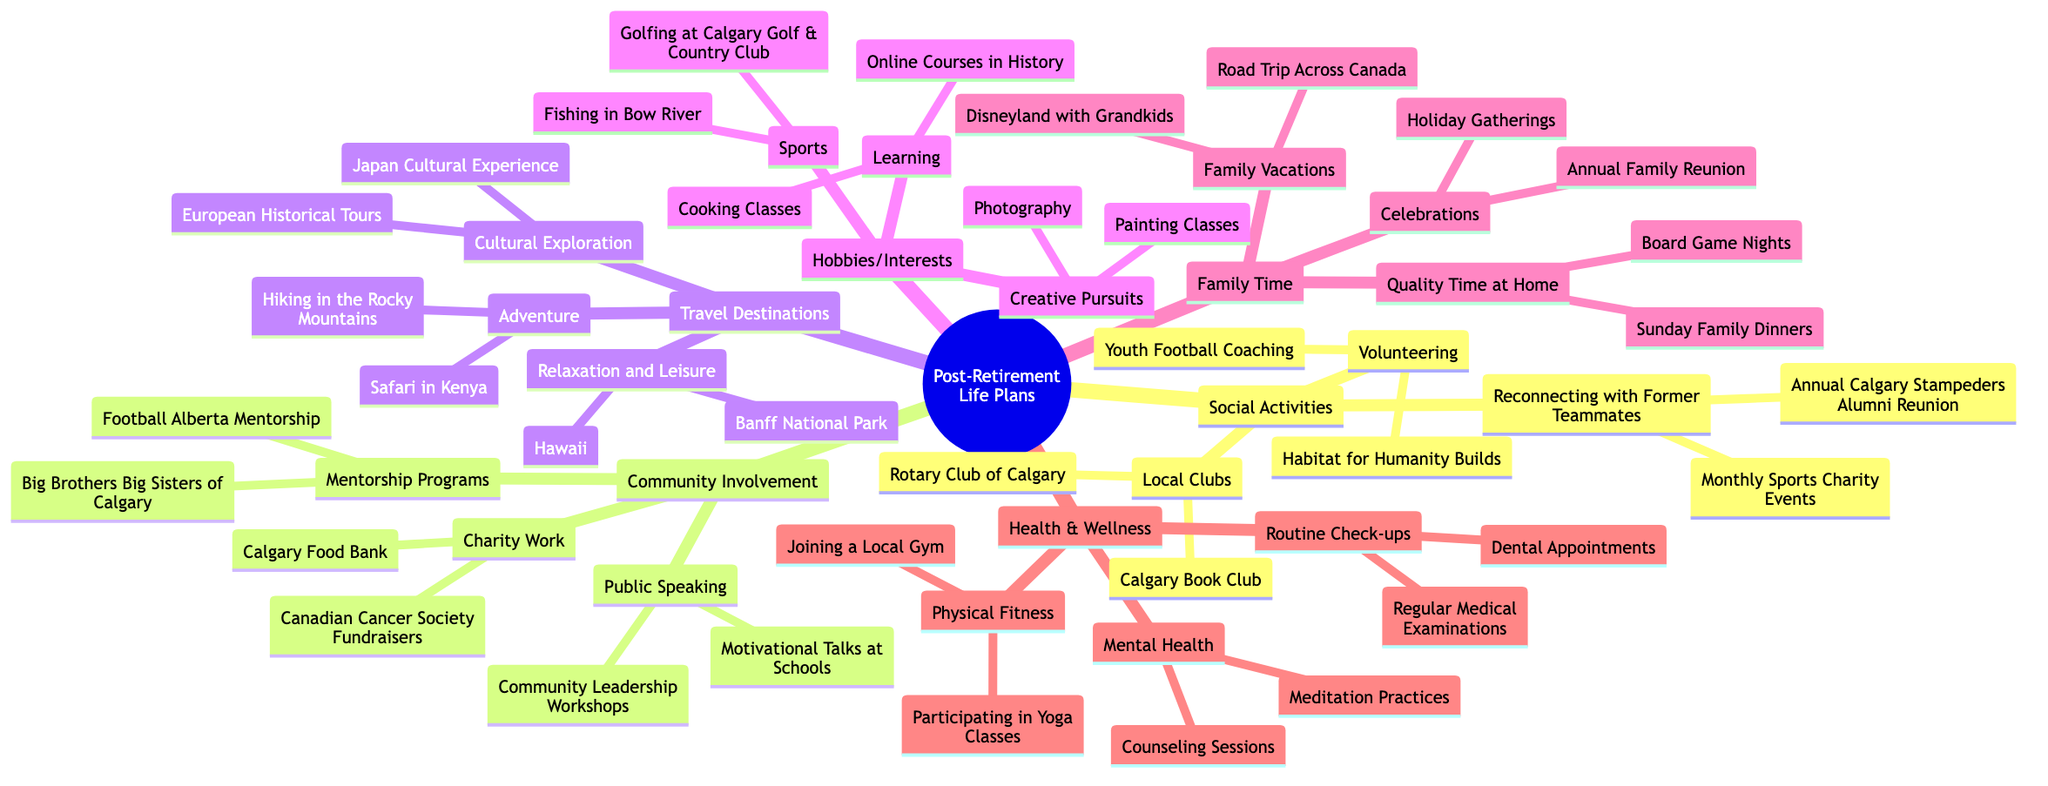What social activity involves reconnecting with former teammates? The diagram shows "Reconnecting with Former Teammates" as a subset of "Social Activities," which includes specific events like "Annual Calgary Stampeders Alumni Reunion" and "Monthly Sports Charity Events." The question asks for one of these activities, which is included in that category.
Answer: Annual Calgary Stampeders Alumni Reunion How many categories are there under "Health & Wellness"? Under the "Health & Wellness" node, there are three subcategories: "Physical Fitness," "Routine Check-ups," and "Mental Health." To determine the number of categories, we simply count these listed subcategories.
Answer: 3 Which travel destination is categorized as "Adventure"? The "Travel Destinations" section lists various categories, one of which is "Adventure." Under this category, "Hiking in the Rocky Mountains" and "Safari in Kenya" are provided as specific adventure activities. The question requires identifying one of these adventure destinations.
Answer: Hiking in the Rocky Mountains What is one activity listed under "Volunteering"? "Volunteering" is a branch of "Social Activities," with specific activities detailed underneath it: "Youth Football Coaching" and "Habitat for Humanity Builds." The question asks for one of the activities under this category, prompting identification from the options listed.
Answer: Youth Football Coaching How does "Family Time" relate to "Family Vacations"? In the mind map, "Family Time" is a main category that includes three sub-categories, with "Family Vacations" as one of them. This indicates that family vacations are a component of the broader concept of time spent with family, thus establishing a direct relationship between the two nodes.
Answer: Family Vacations is a sub-category of Family Time Which community involvement activity is associated with mentorship? The community involvement section contains specific activities, including the "Mentorship Programs" category, which has "Big Brothers Big Sisters of Calgary" and "Football Alberta Mentorship." The question requires identifying one of these activities as associated with mentorship.
Answer: Big Brothers Big Sisters of Calgary What is a creative pursuit listed in the hobbies section? The "Hobbies/Interests" main category contains subcategories, including "Creative Pursuits," which specifically lists "Painting Classes" and "Photography." The question asks for identification of one creative pursuit from those listed under this category.
Answer: Painting Classes Name a health-related activity pertaining to mental health. Within the "Health & Wellness" segment, there is a category for "Mental Health," which specifically includes activities like "Meditation Practices" and "Counseling Sessions." The question requests identification of health-related activities associated with mental health from these options.
Answer: Meditation Practices 